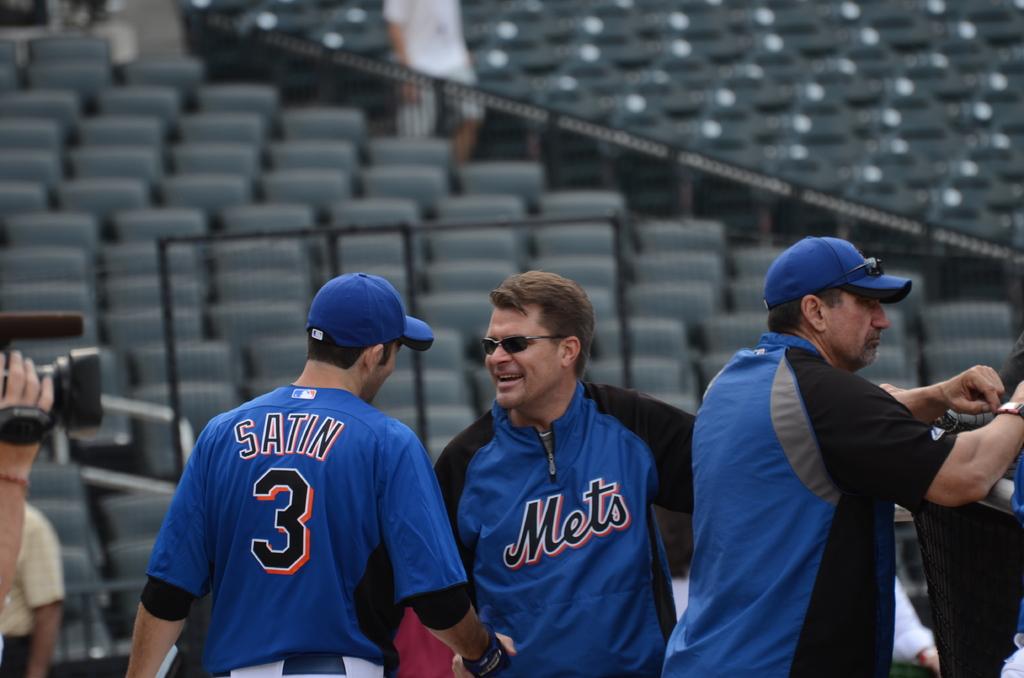What is the name of the man wearing number 3?
Your answer should be compact. Satin. 